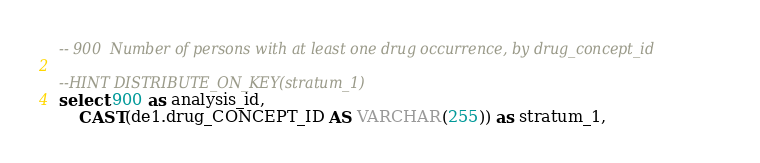Convert code to text. <code><loc_0><loc_0><loc_500><loc_500><_SQL_>-- 900	Number of persons with at least one drug occurrence, by drug_concept_id

--HINT DISTRIBUTE_ON_KEY(stratum_1)
select 900 as analysis_id, 
	CAST(de1.drug_CONCEPT_ID AS VARCHAR(255)) as stratum_1,</code> 